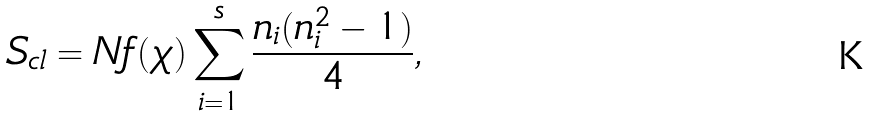Convert formula to latex. <formula><loc_0><loc_0><loc_500><loc_500>S _ { \text {cl} } = N f ( \chi ) \sum _ { i = 1 } ^ { s } \frac { n _ { i } ( n _ { i } ^ { 2 } - 1 ) } { 4 } ,</formula> 